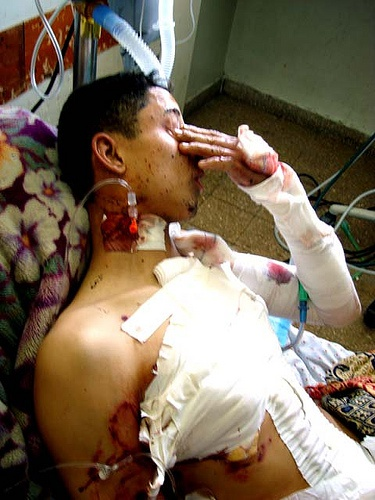Describe the objects in this image and their specific colors. I can see people in lightblue, white, maroon, black, and olive tones and bed in lightblue, black, gray, maroon, and olive tones in this image. 